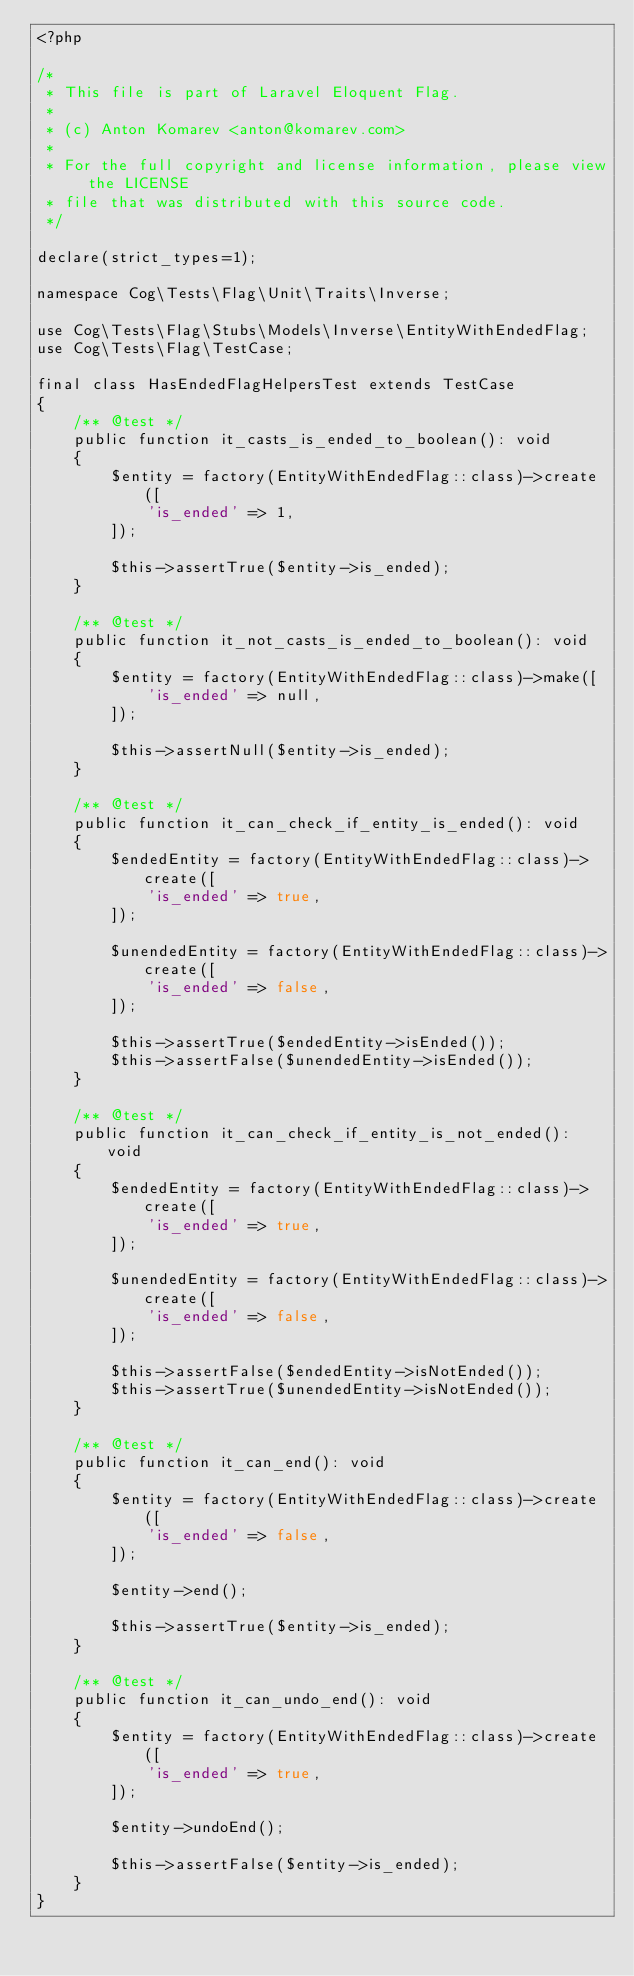<code> <loc_0><loc_0><loc_500><loc_500><_PHP_><?php

/*
 * This file is part of Laravel Eloquent Flag.
 *
 * (c) Anton Komarev <anton@komarev.com>
 *
 * For the full copyright and license information, please view the LICENSE
 * file that was distributed with this source code.
 */

declare(strict_types=1);

namespace Cog\Tests\Flag\Unit\Traits\Inverse;

use Cog\Tests\Flag\Stubs\Models\Inverse\EntityWithEndedFlag;
use Cog\Tests\Flag\TestCase;

final class HasEndedFlagHelpersTest extends TestCase
{
    /** @test */
    public function it_casts_is_ended_to_boolean(): void
    {
        $entity = factory(EntityWithEndedFlag::class)->create([
            'is_ended' => 1,
        ]);

        $this->assertTrue($entity->is_ended);
    }

    /** @test */
    public function it_not_casts_is_ended_to_boolean(): void
    {
        $entity = factory(EntityWithEndedFlag::class)->make([
            'is_ended' => null,
        ]);

        $this->assertNull($entity->is_ended);
    }

    /** @test */
    public function it_can_check_if_entity_is_ended(): void
    {
        $endedEntity = factory(EntityWithEndedFlag::class)->create([
            'is_ended' => true,
        ]);

        $unendedEntity = factory(EntityWithEndedFlag::class)->create([
            'is_ended' => false,
        ]);

        $this->assertTrue($endedEntity->isEnded());
        $this->assertFalse($unendedEntity->isEnded());
    }

    /** @test */
    public function it_can_check_if_entity_is_not_ended(): void
    {
        $endedEntity = factory(EntityWithEndedFlag::class)->create([
            'is_ended' => true,
        ]);

        $unendedEntity = factory(EntityWithEndedFlag::class)->create([
            'is_ended' => false,
        ]);

        $this->assertFalse($endedEntity->isNotEnded());
        $this->assertTrue($unendedEntity->isNotEnded());
    }

    /** @test */
    public function it_can_end(): void
    {
        $entity = factory(EntityWithEndedFlag::class)->create([
            'is_ended' => false,
        ]);

        $entity->end();

        $this->assertTrue($entity->is_ended);
    }

    /** @test */
    public function it_can_undo_end(): void
    {
        $entity = factory(EntityWithEndedFlag::class)->create([
            'is_ended' => true,
        ]);

        $entity->undoEnd();

        $this->assertFalse($entity->is_ended);
    }
}
</code> 